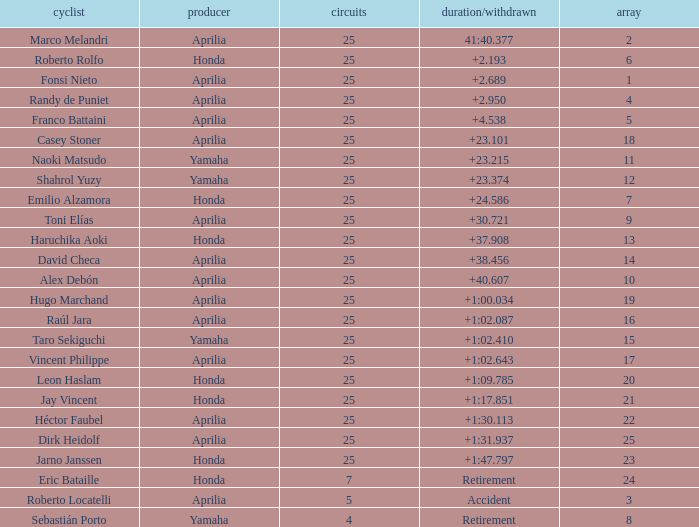Which Laps have a Time/Retired of +23.215, and a Grid larger than 11? None. 